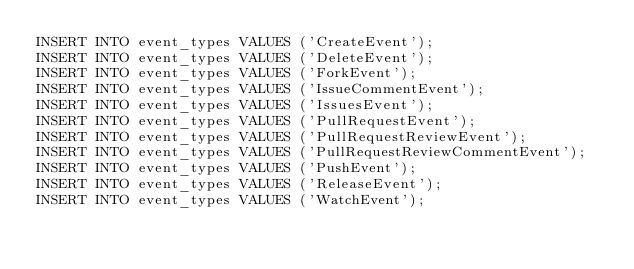Convert code to text. <code><loc_0><loc_0><loc_500><loc_500><_SQL_>INSERT INTO event_types VALUES ('CreateEvent');
INSERT INTO event_types VALUES ('DeleteEvent');
INSERT INTO event_types VALUES ('ForkEvent');
INSERT INTO event_types VALUES ('IssueCommentEvent');
INSERT INTO event_types VALUES ('IssuesEvent');
INSERT INTO event_types VALUES ('PullRequestEvent');
INSERT INTO event_types VALUES ('PullRequestReviewEvent');
INSERT INTO event_types VALUES ('PullRequestReviewCommentEvent');
INSERT INTO event_types VALUES ('PushEvent');
INSERT INTO event_types VALUES ('ReleaseEvent');
INSERT INTO event_types VALUES ('WatchEvent');
</code> 